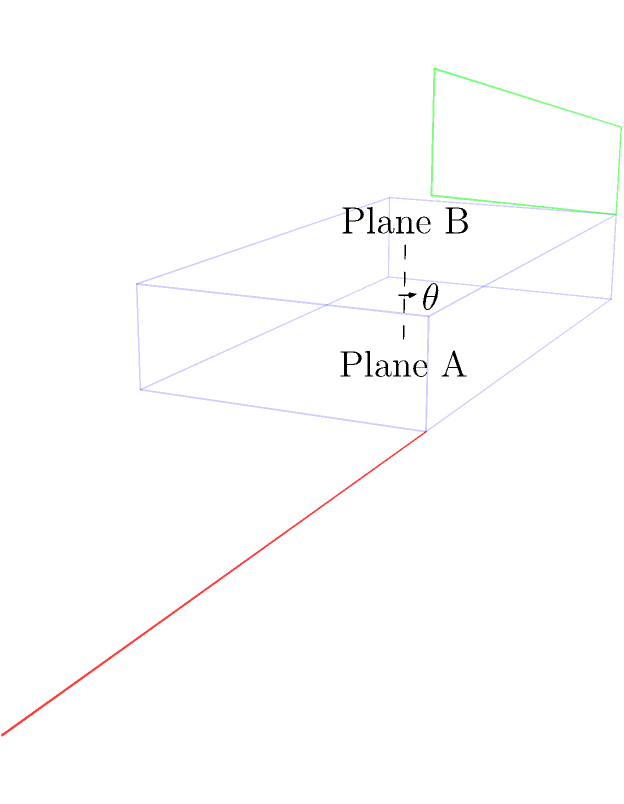In a 3D model of a handball court, two planes are identified: Plane A represents the floor, and Plane B represents the ceiling. Both planes are parallel and separated by a height of 7 meters. If a line is drawn perpendicular to both planes, what is the angle $\theta$ between these two planes? To determine the angle between two planes, we can follow these steps:

1) In this case, the planes are parallel, which simplifies our calculation.

2) When two planes are parallel, the angle between them is either 0° or 180°.

3) To distinguish between these two options, we need to consider the orientation of the planes:
   - If the planes face the same direction, the angle is 0°.
   - If the planes face opposite directions, the angle is 180°.

4) In a handball court, the floor (Plane A) and ceiling (Plane B) face opposite directions:
   - The floor's normal vector points upward.
   - The ceiling's normal vector points downward.

5) Therefore, the angle between these two planes is 180°.

Note: This result is independent of the court's dimensions or the distance between the planes. As long as the floor and ceiling are parallel, the angle between them will always be 180°.
Answer: 180° 